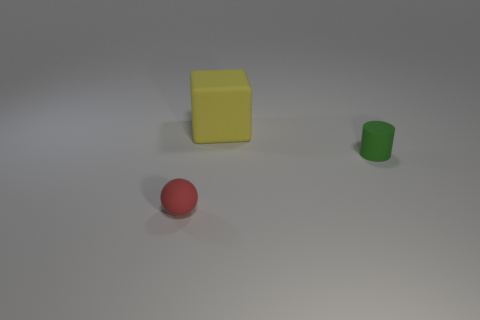Add 2 small green matte cylinders. How many objects exist? 5 Subtract all spheres. How many objects are left? 2 Subtract all small green things. Subtract all green rubber cylinders. How many objects are left? 1 Add 3 blocks. How many blocks are left? 4 Add 1 small matte things. How many small matte things exist? 3 Subtract 0 green balls. How many objects are left? 3 